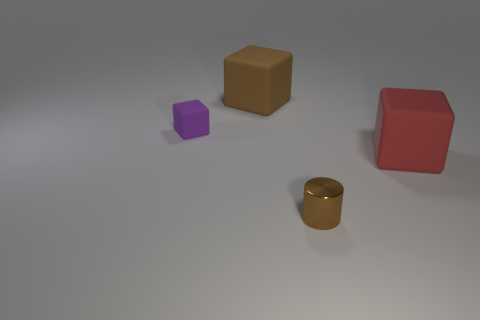Subtract all large blocks. How many blocks are left? 1 Subtract all purple blocks. How many blocks are left? 2 Add 4 cylinders. How many objects exist? 8 Subtract all blocks. How many objects are left? 1 Subtract all tiny brown cylinders. Subtract all big gray matte cubes. How many objects are left? 3 Add 1 shiny objects. How many shiny objects are left? 2 Add 1 big yellow rubber cubes. How many big yellow rubber cubes exist? 1 Subtract 1 red cubes. How many objects are left? 3 Subtract all purple blocks. Subtract all cyan balls. How many blocks are left? 2 